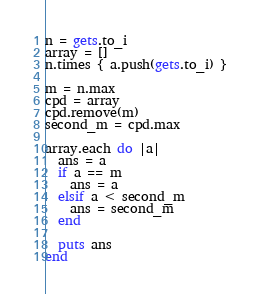Convert code to text. <code><loc_0><loc_0><loc_500><loc_500><_Ruby_>n = gets.to_i
array = []
n.times { a.push(gets.to_i) }

m = n.max
cpd = array
cpd.remove(m)
second_m = cpd.max

array.each do |a|
  ans = a
  if a == m
    ans = a
  elsif a < second_m
    ans = second_m
  end

  puts ans
end
</code> 